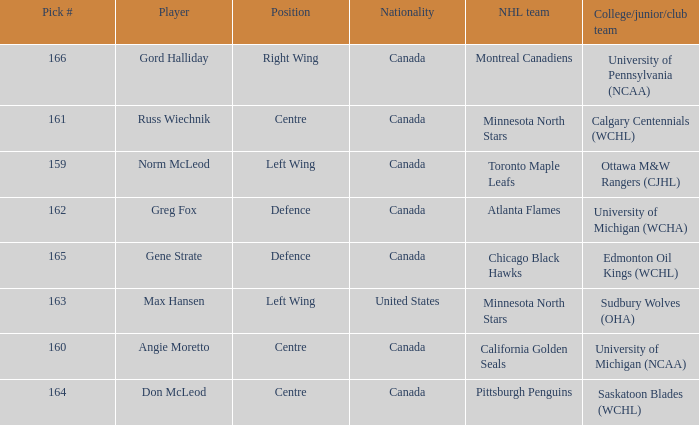What team did Russ Wiechnik, on the centre position, come from? Calgary Centennials (WCHL). 